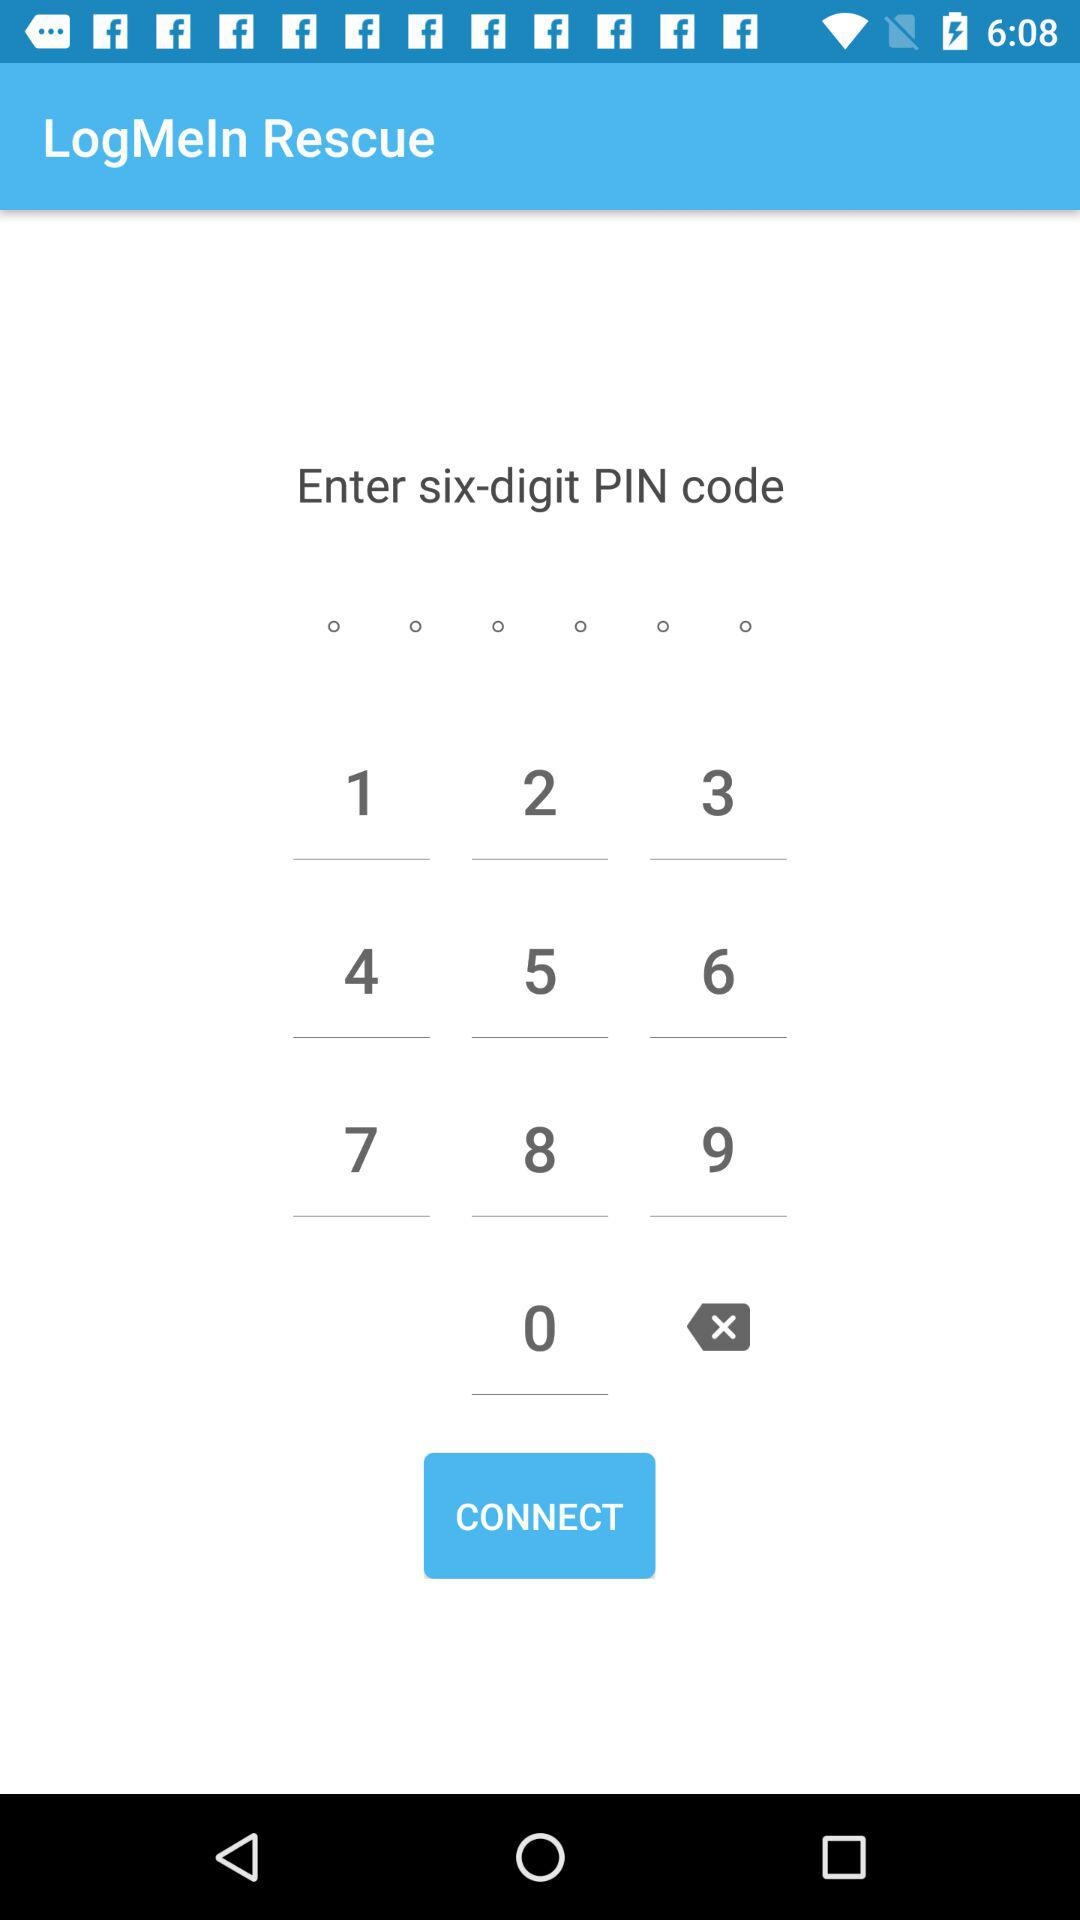What 6 digit pin code has been entered?
When the provided information is insufficient, respond with <no answer>. <no answer> 